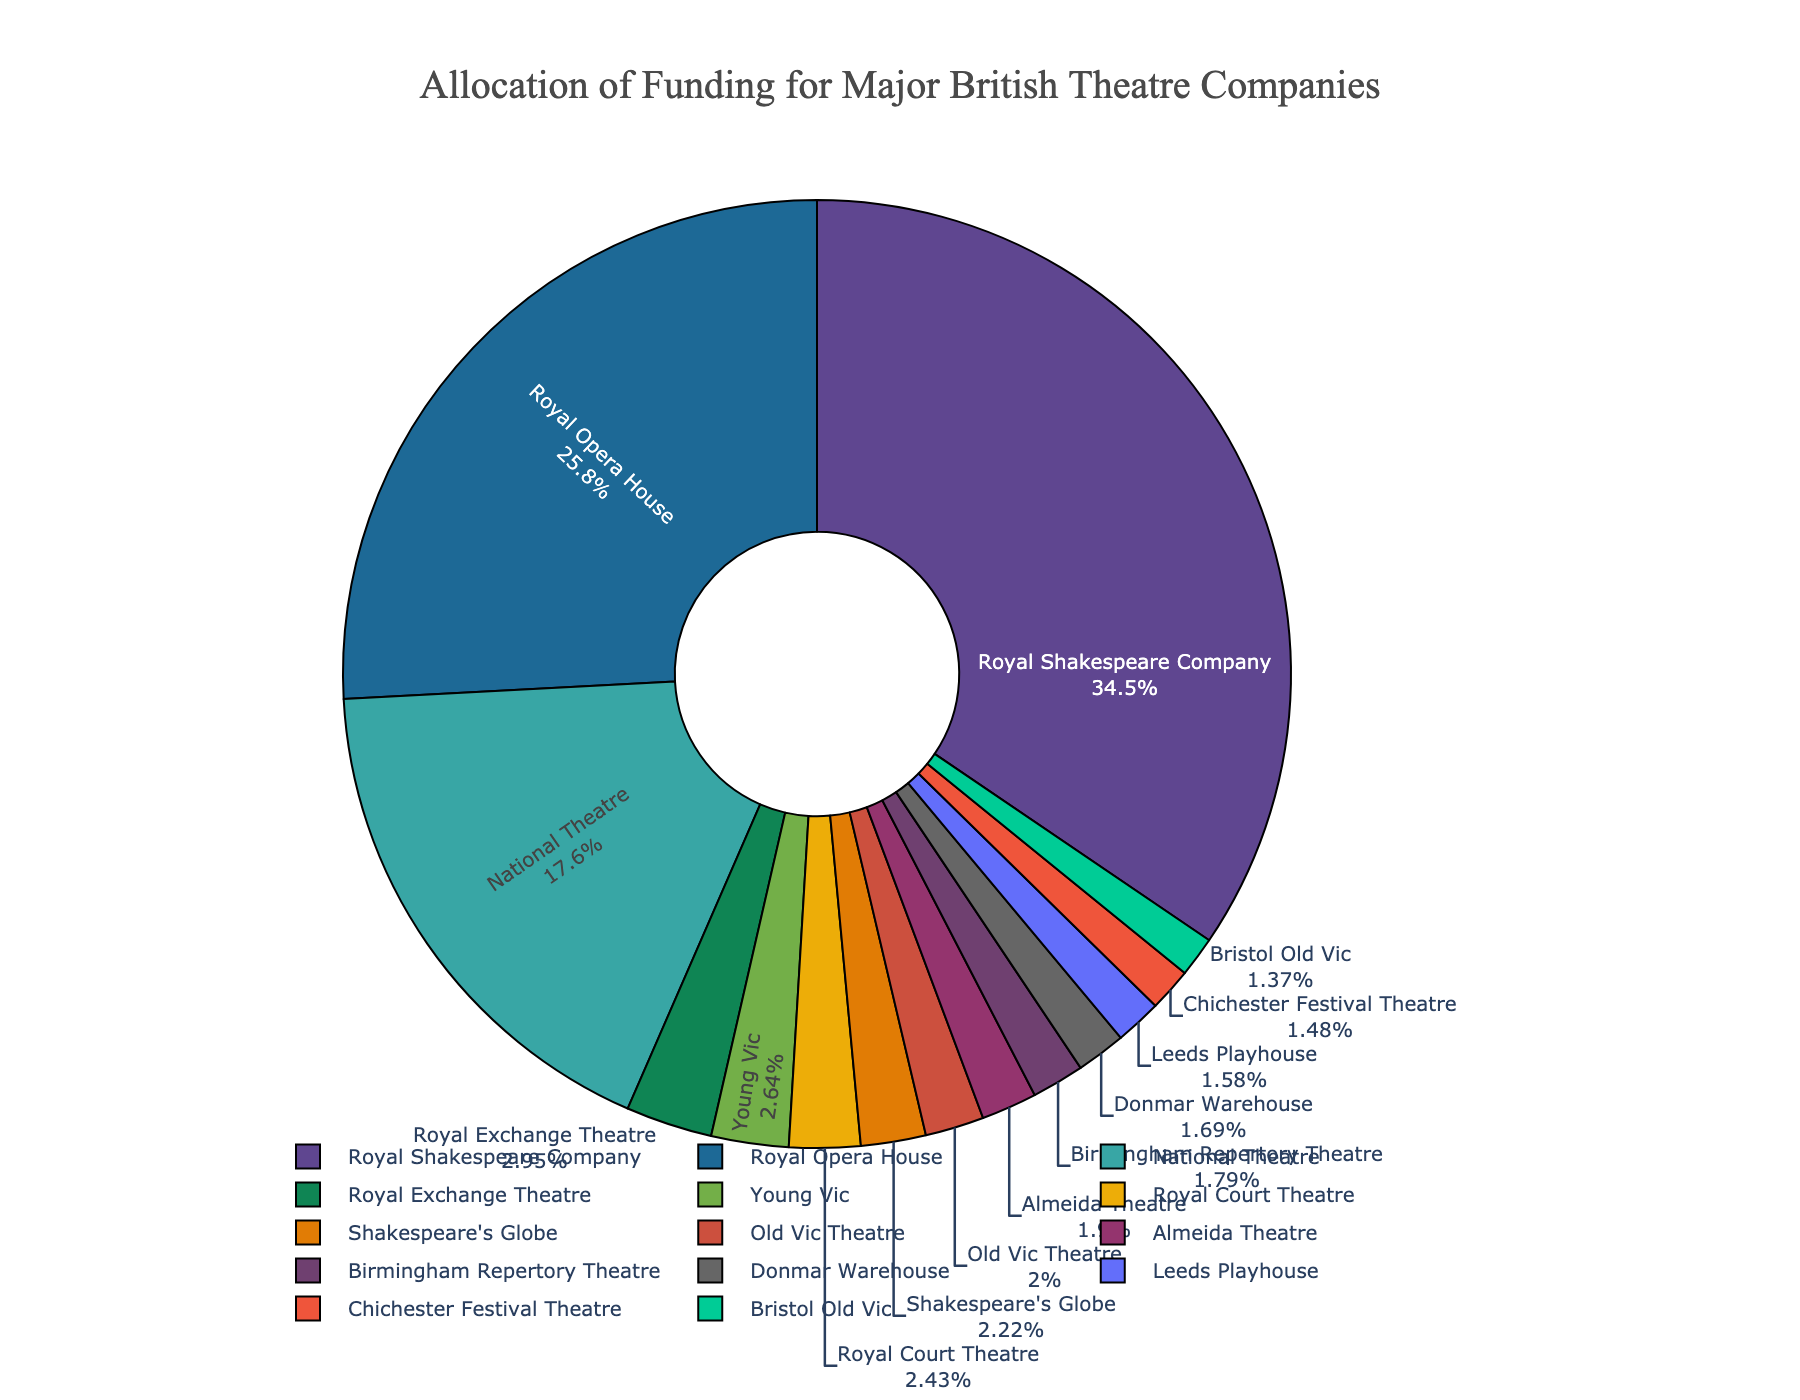What percentage of the total funding allocation goes to the Royal Shakespeare Company? The figure shows the Royal Shakespeare Company has £32.7 million allocated. To find the percentage, sum up the total funding of all companies first. This results in a total allocation of £96.8 million (32.7 + 16.7 + 24.5 + 2.8 + 1.9 + 2.1 + 1.6 + 1.8 + 2.3 + 2.5 + 1.4 + 1.7 + 1.3 + 1.5). Then, calculate (32.7 / 96.8) * 100% ≈ 33.8%.
Answer: 33.8% Which two theatre companies have the smallest funding allocation, and what is their combined allocation? From the pie chart, the smallest funding allocations are to Bristol Old Vic (£1.3 million) and Chichester Festival Theatre (£1.4 million). Their combined allocation is 1.3 + 1.4 = £2.7 million.
Answer: £2.7 million How does the funding allocation for the National Theatre compare to that of the Royal Opera House? The figure shows the National Theatre has £16.7 million and the Royal Opera House has £24.5 million. Comparing these, the Royal Opera House has (24.5 - 16.7) = £7.8 million more funding allocation than the National Theatre.
Answer: £7.8 million What is the total funding allocation for all theatres except the top three funded ones? The top three theatres are Royal Shakespeare Company (£32.7 million), Royal Opera House (£24.5 million), and National Theatre (£16.7 million). Excluding these, sum up the allocations of the remaining theatres: 2.8 + 1.9 + 2.1 + 1.6 + 1.8 + 2.3 + 2.5 + 1.4 + 1.7 + 1.3 + 1.5 = £21.9 million.
Answer: £21.9 million What is the average funding allocation per theatre company? The total funding allocation is £96.8 million, and there are 14 theatre companies. Calculate the average by dividing the total allocation by the number of companies: 96.8 / 14 ≈ £6.9 million.
Answer: £6.9 million Does Shakespeare's Globe receive more or less funding than the sum of the Old Vic Theatre and the Donmar Warehouse? Shakespeare's Globe receives £2.1 million. The Old Vic Theatre and Donmar Warehouse together receive 1.9 + 1.6 = £3.5 million. Compare these to find that the sum of the Old Vic Theatre and Donmar Warehouse is greater.
Answer: Less Which theatre company receives closest to 2% of the total funding allocation? The total funding allocation is £96.8 million, and 2% of this is approximately 1.936 million. By comparing each theatre's funding allocation, Almeida Theatre's £1.8 million is the closest to this value (2% of £96.8 million).
Answer: Almeida Theatre What is the difference in funding allocation between the highest funded and the lowest funded theatre companies? The highest funded is the Royal Shakespeare Company with £32.7 million, and the lowest funded is Bristol Old Vic with £1.3 million. The difference is 32.7 - 1.3 = £31.4 million.
Answer: £31.4 million 